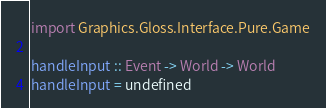<code> <loc_0><loc_0><loc_500><loc_500><_Haskell_>
import Graphics.Gloss.Interface.Pure.Game

handleInput :: Event -> World -> World
handleInput = undefined
</code> 